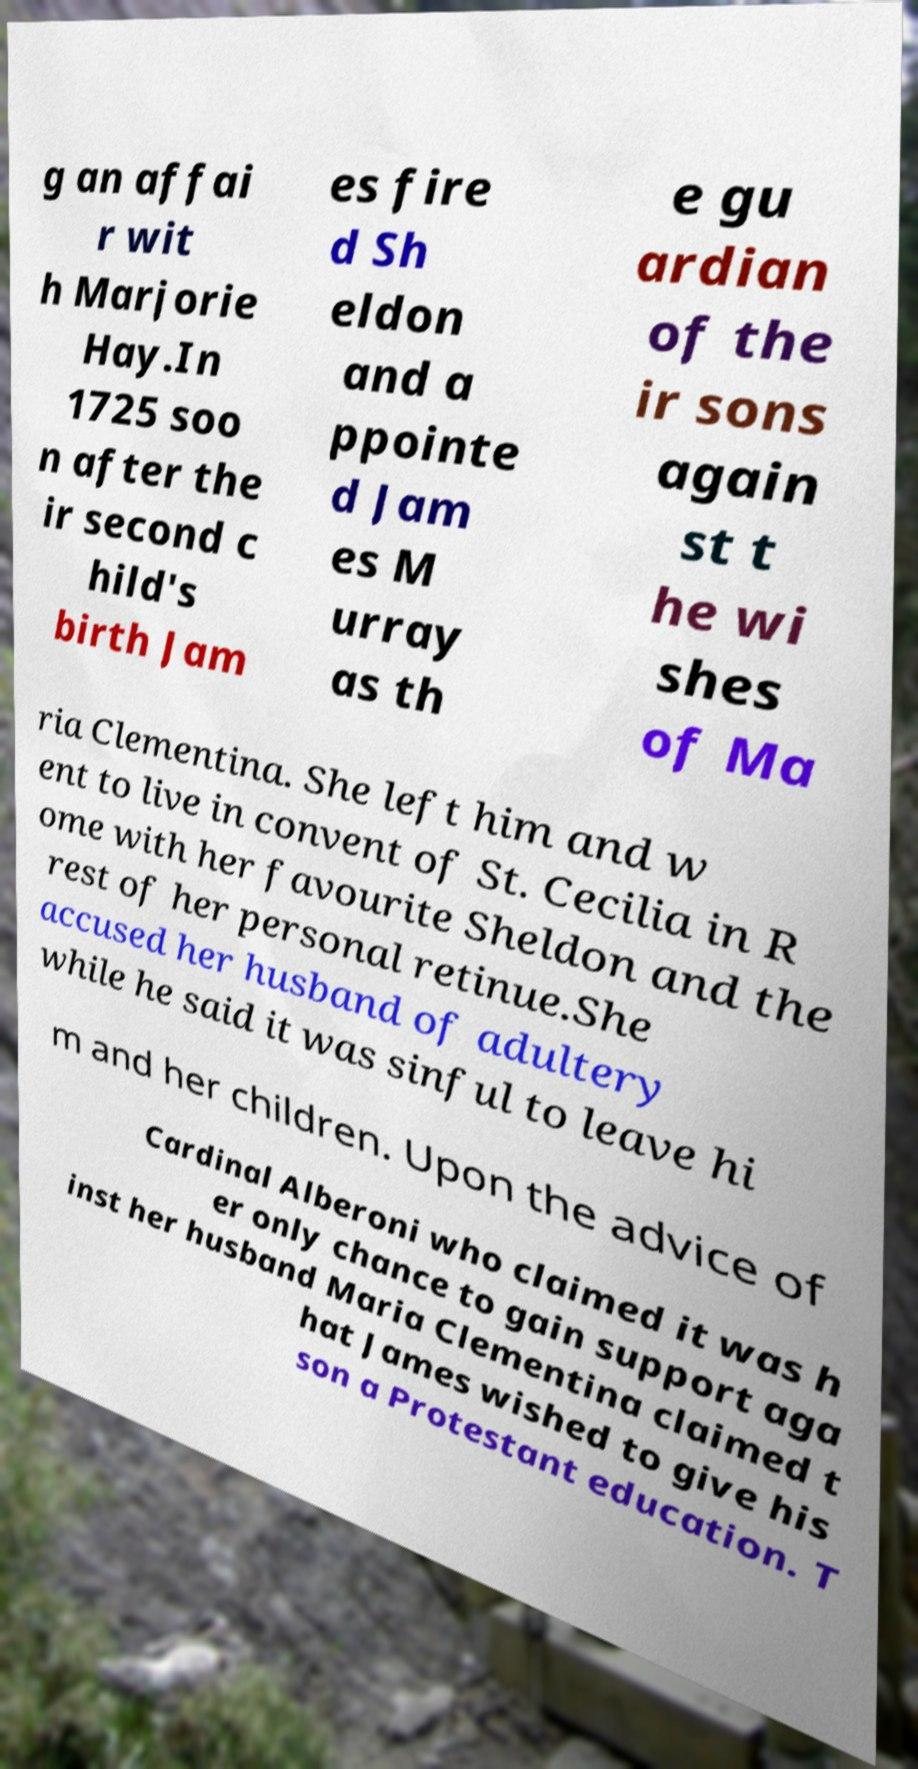I need the written content from this picture converted into text. Can you do that? g an affai r wit h Marjorie Hay.In 1725 soo n after the ir second c hild's birth Jam es fire d Sh eldon and a ppointe d Jam es M urray as th e gu ardian of the ir sons again st t he wi shes of Ma ria Clementina. She left him and w ent to live in convent of St. Cecilia in R ome with her favourite Sheldon and the rest of her personal retinue.She accused her husband of adultery while he said it was sinful to leave hi m and her children. Upon the advice of Cardinal Alberoni who claimed it was h er only chance to gain support aga inst her husband Maria Clementina claimed t hat James wished to give his son a Protestant education. T 